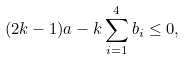Convert formula to latex. <formula><loc_0><loc_0><loc_500><loc_500>( 2 k - 1 ) a - k \sum _ { i = 1 } ^ { 4 } b _ { i } \leq 0 ,</formula> 